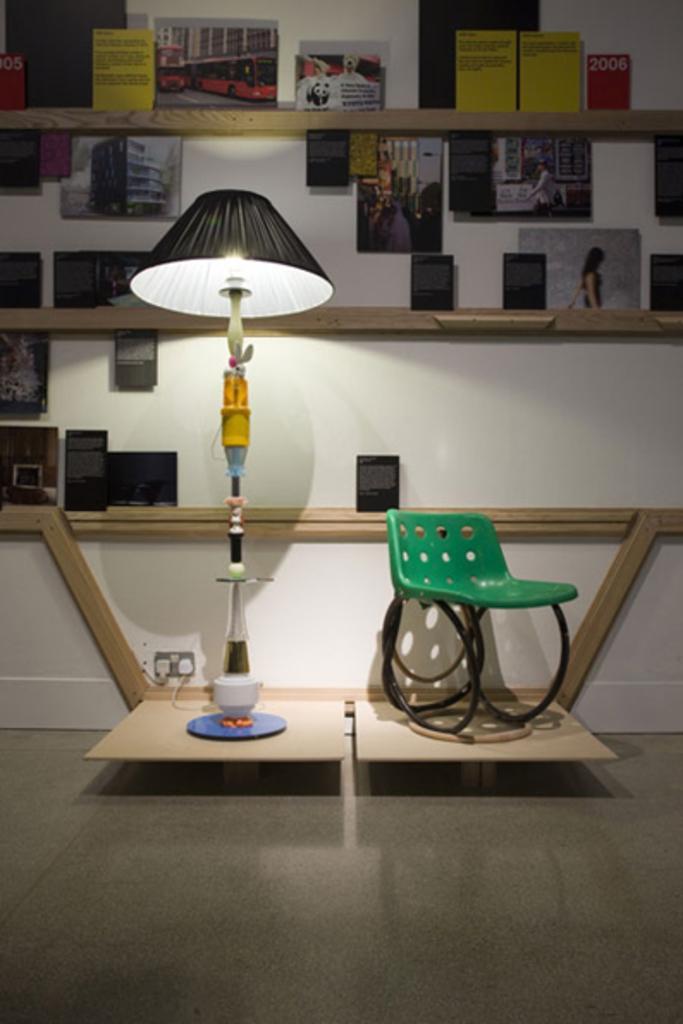How would you summarize this image in a sentence or two? As we can see in the image there is a lamp, chair, switch board, shelves, white color wall and photo frames. 